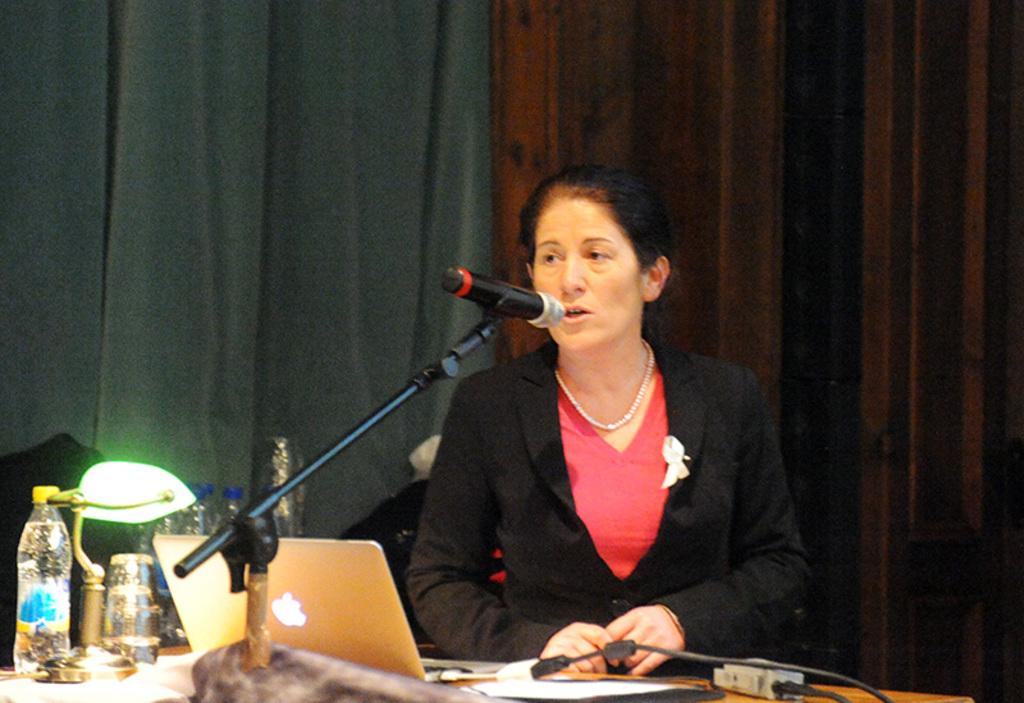What is the person in the image wearing? The person in the image is wearing a black and red color dress. What can be seen on the table in the image? There are objects on the table in the image. What is the person holding in the image? The person is holding a mic in the image. What is the background of the image? The background of the image includes a curtain. What electronic device is present in the image? There is a laptop in the image. What type of quiver can be seen in the image? There is no quiver present in the image. What part of the person's flesh is visible in the image? The image does not show any visible flesh of the person. 